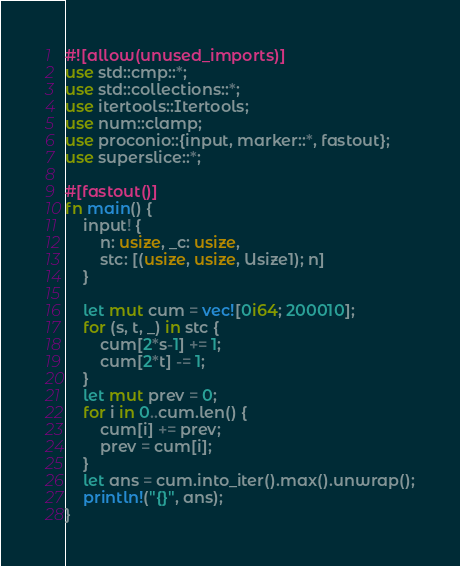<code> <loc_0><loc_0><loc_500><loc_500><_Rust_>#![allow(unused_imports)]
use std::cmp::*;
use std::collections::*;
use itertools::Itertools;
use num::clamp;
use proconio::{input, marker::*, fastout};
use superslice::*;

#[fastout()]
fn main() {
    input! {
        n: usize, _c: usize,
        stc: [(usize, usize, Usize1); n]
    }

    let mut cum = vec![0i64; 200010];
    for (s, t, _) in stc {
        cum[2*s-1] += 1;
        cum[2*t] -= 1;
    }
    let mut prev = 0;
    for i in 0..cum.len() {
        cum[i] += prev;
        prev = cum[i];
    }
    let ans = cum.into_iter().max().unwrap();
    println!("{}", ans);
}
</code> 